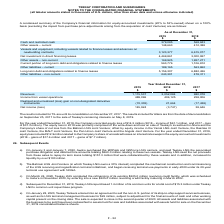According to Teekay Corporation's financial document, How much was the equity loss for the year ended December 31, 2019? According to the financial document, $14.5 million. The relevant text states: "mber 31, 2019, the Company recorded equity loss of $14.5 million (2018 – income of $61.1 million, and 2017 – loss of $37.3 million). The equity loss in 2019 was prim..." Also, can you calculate: What is the change in Cash and restricted cash from December 31, 2019 to December 31, 2018? Based on the calculation: 379,085-568,843, the result is -189758 (in thousands). This is based on the information: "Cash and restricted cash 379,085 568,843 Cash and restricted cash 379,085 568,843..." The key data points involved are: 379,085, 568,843. Also, can you calculate: What is the change in Other assets – current from December 31, 2019 to December 31, 2018? Based on the calculation: 148,663-412,388, the result is -263725 (in thousands). This is based on the information: "Other assets – current 148,663 412,388 Other assets – current 148,663 412,388..." The key data points involved are: 148,663, 412,388. Additionally, In which year was cash and restricted cash less than 400,000 thousand? According to the financial document, 2019. The relevant text states: "2019..." Also, What was the other assets - current in 2019 and 2018 respectively? The document shows two values: 148,663 and 412,388 (in thousands). From the document: "Other assets – current 148,663 412,388 Other assets – current 148,663 412,388..." Also, What was the other liabilities - non current in 2019 and 2018 respectively? The document shows two values: 243,301 and 478,311 (in thousands). From the document: "Other liabilities – non-current 243,301 478,311 Other liabilities – non-current 243,301 478,311..." 